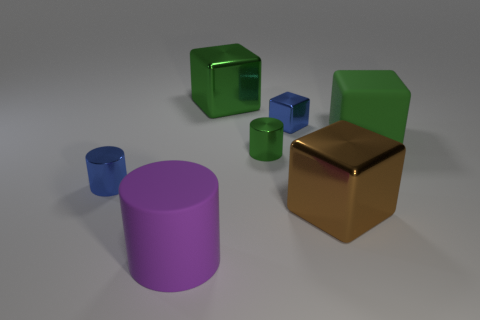How many large purple rubber objects are there? 1 